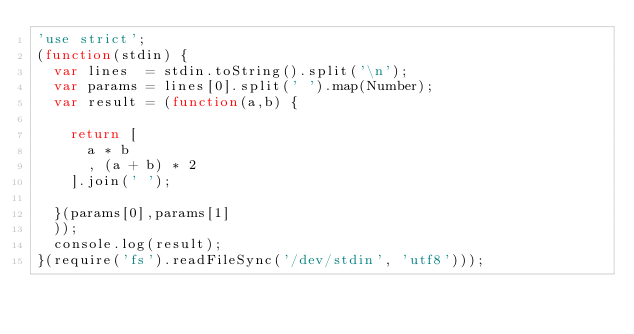<code> <loc_0><loc_0><loc_500><loc_500><_JavaScript_>'use strict';
(function(stdin) {
  var lines  = stdin.toString().split('\n');
  var params = lines[0].split(' ').map(Number);
  var result = (function(a,b) {

    return [
      a * b
      , (a + b) * 2
    ].join(' ');

  }(params[0],params[1]
  ));
  console.log(result);
}(require('fs').readFileSync('/dev/stdin', 'utf8')));</code> 